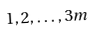<formula> <loc_0><loc_0><loc_500><loc_500>1 , 2 , \dots , 3 m</formula> 